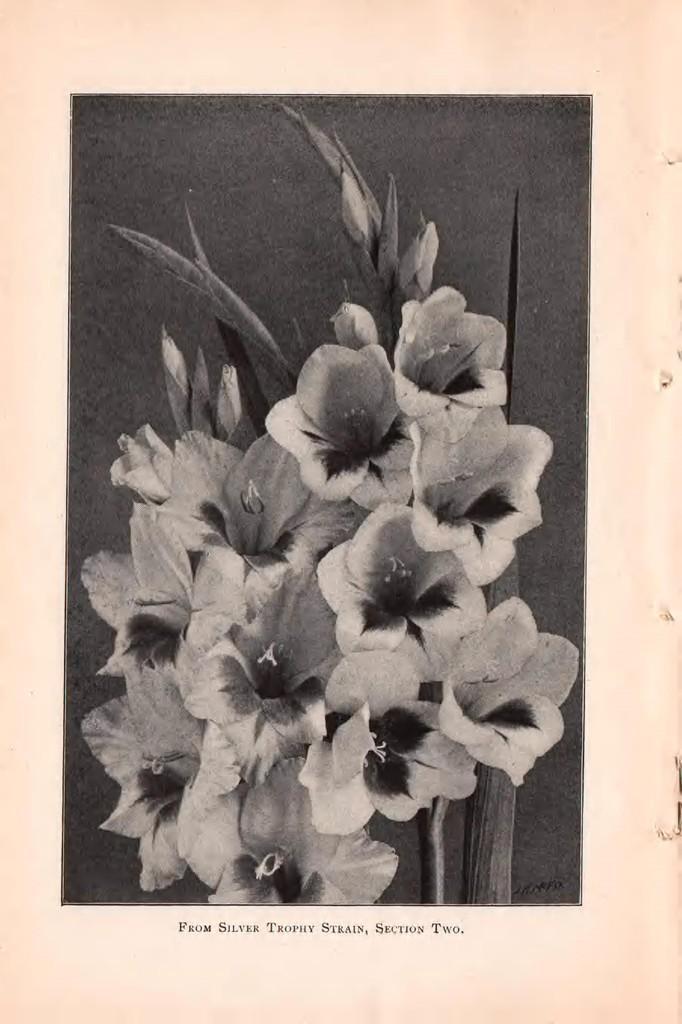Could you give a brief overview of what you see in this image? This is a black and white photo. In the center of the image we can see the flowers, leaves. At the bottom of the image we can see the text. 